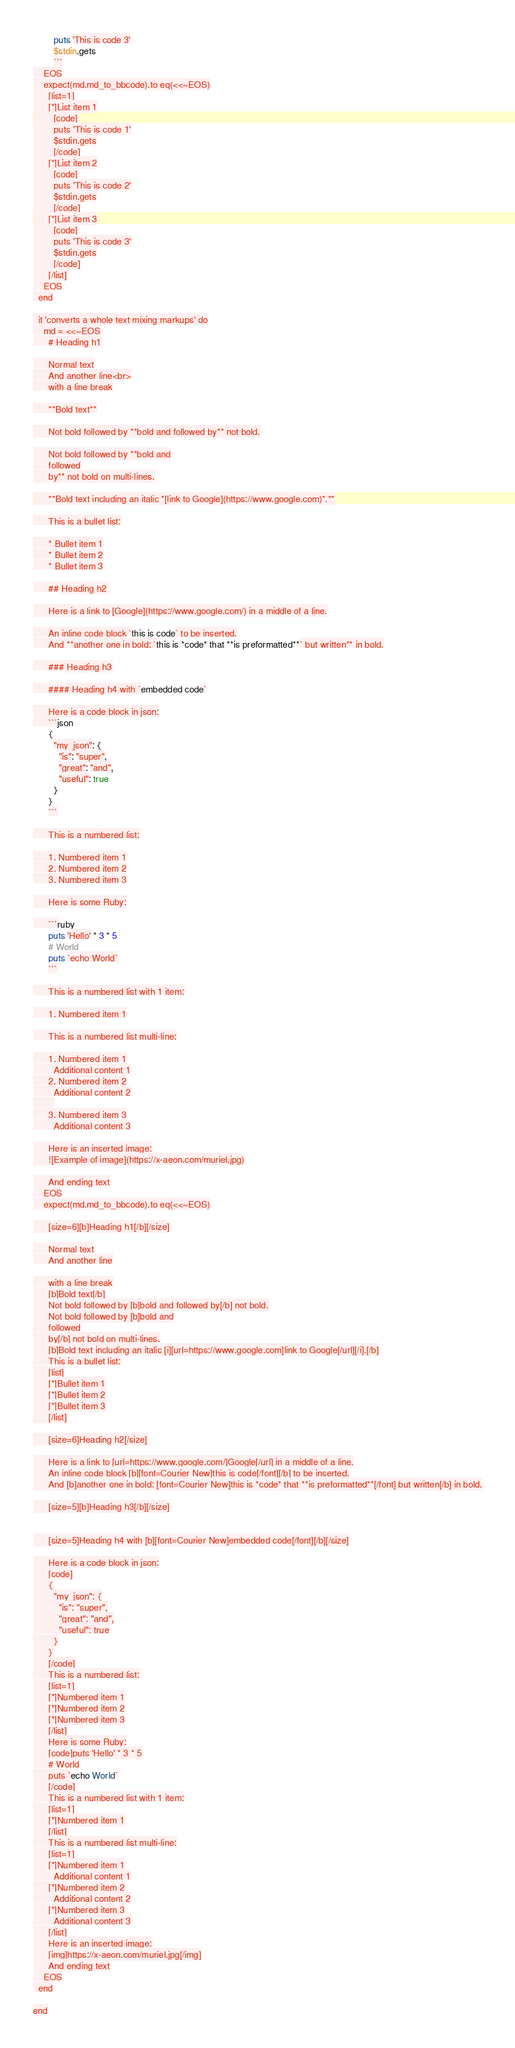<code> <loc_0><loc_0><loc_500><loc_500><_Ruby_>        puts 'This is code 3'
        $stdin.gets
        ```
    EOS
    expect(md.md_to_bbcode).to eq(<<~EOS)
      [list=1]
      [*]List item 1
        [code]
        puts 'This is code 1'
        $stdin.gets
        [/code]
      [*]List item 2
        [code]
        puts 'This is code 2'
        $stdin.gets
        [/code]
      [*]List item 3
        [code]
        puts 'This is code 3'
        $stdin.gets
        [/code]
      [/list]
    EOS
  end

  it 'converts a whole text mixing markups' do
    md = <<~EOS
      # Heading h1

      Normal text
      And another line<br>
      with a line break

      **Bold text**

      Not bold followed by **bold and followed by** not bold.

      Not bold followed by **bold and
      followed
      by** not bold on multi-lines.

      **Bold text including an italic *[link to Google](https://www.google.com)*.**

      This is a bullet list:

      * Bullet item 1
      * Bullet item 2
      * Bullet item 3

      ## Heading h2

      Here is a link to [Google](https://www.google.com/) in a middle of a line.

      An inline code block `this is code` to be inserted.
      And **another one in bold: `this is *code* that **is preformatted**` but written** in bold.

      ### Heading h3

      #### Heading h4 with `embedded code`

      Here is a code block in json:
      ```json
      {
        "my_json": {
          "is": "super",
          "great": "and",
          "useful": true
        }
      }
      ```

      This is a numbered list:

      1. Numbered item 1
      2. Numbered item 2
      3. Numbered item 3

      Here is some Ruby:

      ```ruby
      puts 'Hello' * 3 * 5
      # World
      puts `echo World`
      ```

      This is a numbered list with 1 item:

      1. Numbered item 1

      This is a numbered list multi-line:

      1. Numbered item 1
        Additional content 1
      2. Numbered item 2
        Additional content 2
        
      3. Numbered item 3
        Additional content 3

      Here is an inserted image:
      ![Example of image](https://x-aeon.com/muriel.jpg)

      And ending text
    EOS
    expect(md.md_to_bbcode).to eq(<<~EOS)

      [size=6][b]Heading h1[/b][/size]

      Normal text
      And another line

      with a line break
      [b]Bold text[/b]
      Not bold followed by [b]bold and followed by[/b] not bold.
      Not bold followed by [b]bold and
      followed
      by[/b] not bold on multi-lines.
      [b]Bold text including an italic [i][url=https://www.google.com]link to Google[/url][/i].[/b]
      This is a bullet list:
      [list]
      [*]Bullet item 1
      [*]Bullet item 2
      [*]Bullet item 3
      [/list]

      [size=6]Heading h2[/size]

      Here is a link to [url=https://www.google.com/]Google[/url] in a middle of a line.
      An inline code block [b][font=Courier New]this is code[/font][/b] to be inserted.
      And [b]another one in bold: [font=Courier New]this is *code* that **is preformatted**[/font] but written[/b] in bold.

      [size=5][b]Heading h3[/b][/size]


      [size=5]Heading h4 with [b][font=Courier New]embedded code[/font][/b][/size]

      Here is a code block in json:
      [code]
      {
        "my_json": {
          "is": "super",
          "great": "and",
          "useful": true
        }
      }
      [/code]
      This is a numbered list:
      [list=1]
      [*]Numbered item 1
      [*]Numbered item 2
      [*]Numbered item 3
      [/list]
      Here is some Ruby:
      [code]puts 'Hello' * 3 * 5
      # World
      puts `echo World`
      [/code]
      This is a numbered list with 1 item:
      [list=1]
      [*]Numbered item 1
      [/list]
      This is a numbered list multi-line:
      [list=1]
      [*]Numbered item 1
        Additional content 1
      [*]Numbered item 2
        Additional content 2
      [*]Numbered item 3
        Additional content 3
      [/list]
      Here is an inserted image:
      [img]https://x-aeon.com/muriel.jpg[/img]
      And ending text
    EOS
  end

end
</code> 